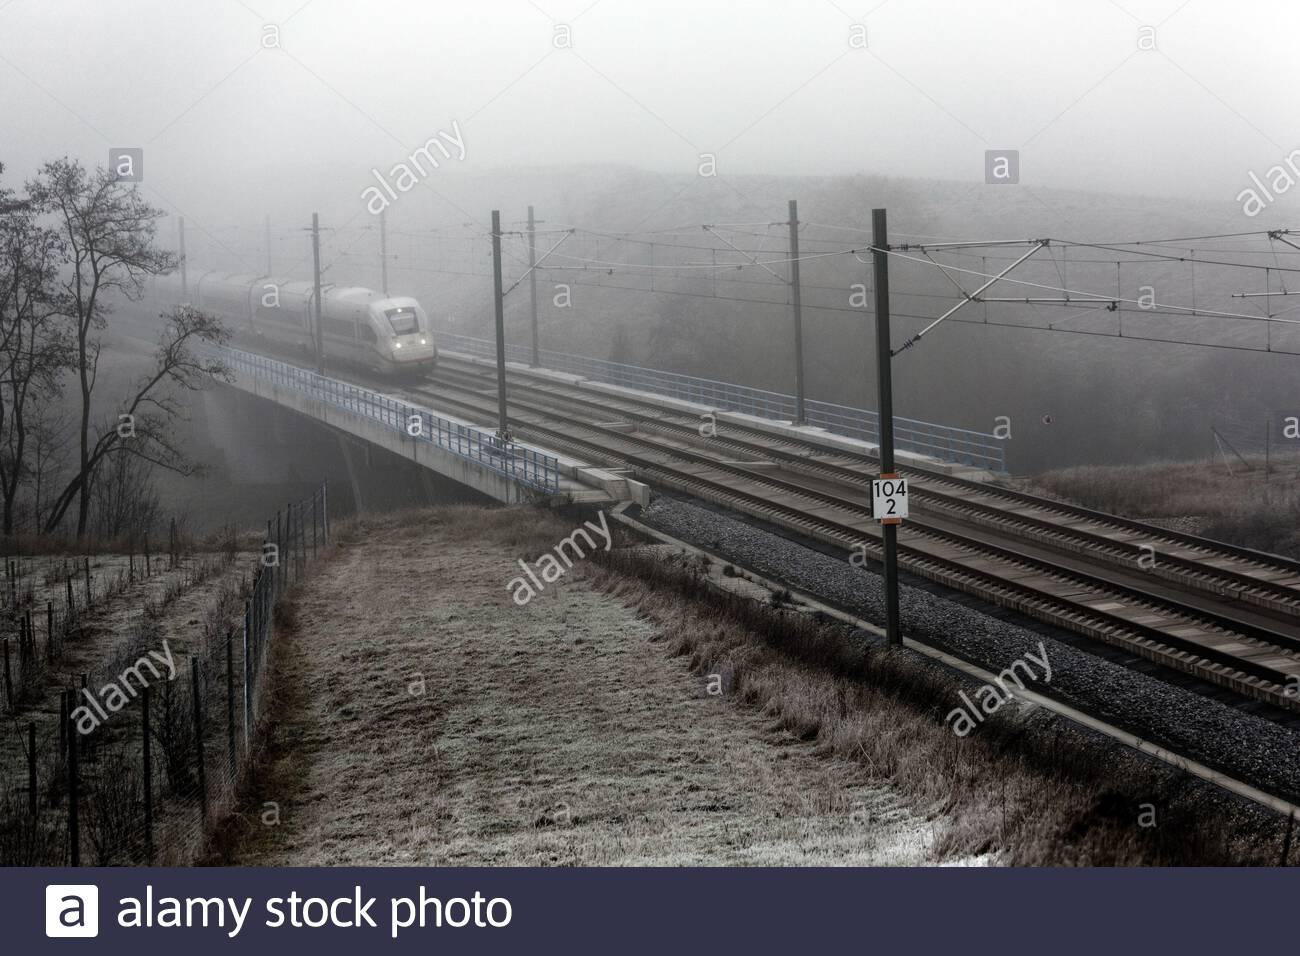How many unicorns are there in the image? There are no unicorns visible in the image, as it depicts a modern train traveling over a bridge in a foggy, rural setting. 